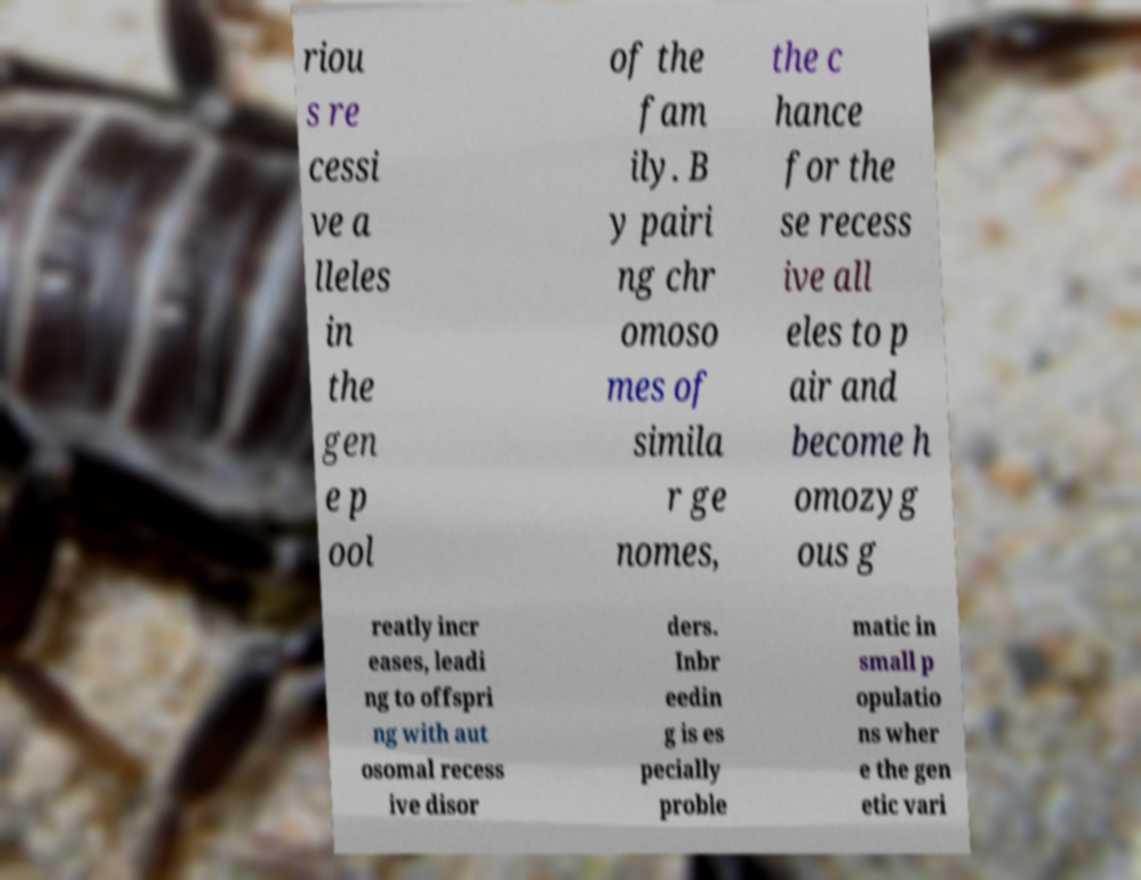Can you accurately transcribe the text from the provided image for me? riou s re cessi ve a lleles in the gen e p ool of the fam ily. B y pairi ng chr omoso mes of simila r ge nomes, the c hance for the se recess ive all eles to p air and become h omozyg ous g reatly incr eases, leadi ng to offspri ng with aut osomal recess ive disor ders. Inbr eedin g is es pecially proble matic in small p opulatio ns wher e the gen etic vari 